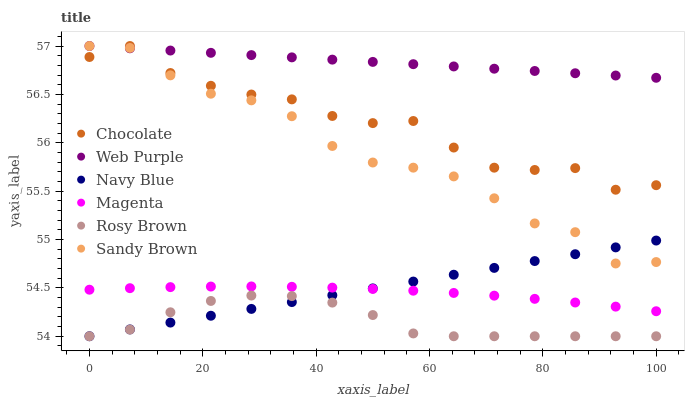Does Rosy Brown have the minimum area under the curve?
Answer yes or no. Yes. Does Web Purple have the maximum area under the curve?
Answer yes or no. Yes. Does Chocolate have the minimum area under the curve?
Answer yes or no. No. Does Chocolate have the maximum area under the curve?
Answer yes or no. No. Is Navy Blue the smoothest?
Answer yes or no. Yes. Is Chocolate the roughest?
Answer yes or no. Yes. Is Rosy Brown the smoothest?
Answer yes or no. No. Is Rosy Brown the roughest?
Answer yes or no. No. Does Navy Blue have the lowest value?
Answer yes or no. Yes. Does Chocolate have the lowest value?
Answer yes or no. No. Does Sandy Brown have the highest value?
Answer yes or no. Yes. Does Rosy Brown have the highest value?
Answer yes or no. No. Is Navy Blue less than Chocolate?
Answer yes or no. Yes. Is Chocolate greater than Magenta?
Answer yes or no. Yes. Does Rosy Brown intersect Navy Blue?
Answer yes or no. Yes. Is Rosy Brown less than Navy Blue?
Answer yes or no. No. Is Rosy Brown greater than Navy Blue?
Answer yes or no. No. Does Navy Blue intersect Chocolate?
Answer yes or no. No. 